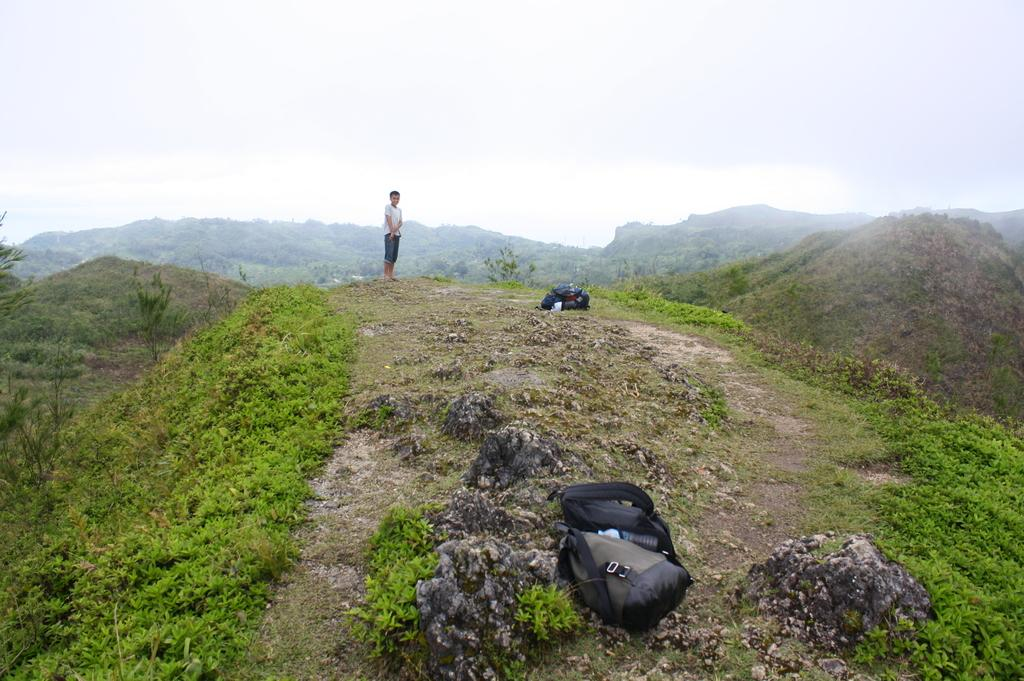What is the person in the image doing? There is a person standing on the ground in the image. What items can be seen near the person? There are bags visible in the image. What type of vegetation is present in the image? There are plants and grass in the image. What can be seen in the distance in the image? There are mountains in the background of the image, and the sky is visible as well. What type of crate is being used to hold the letters in the image? There is no crate or letters present in the image. 